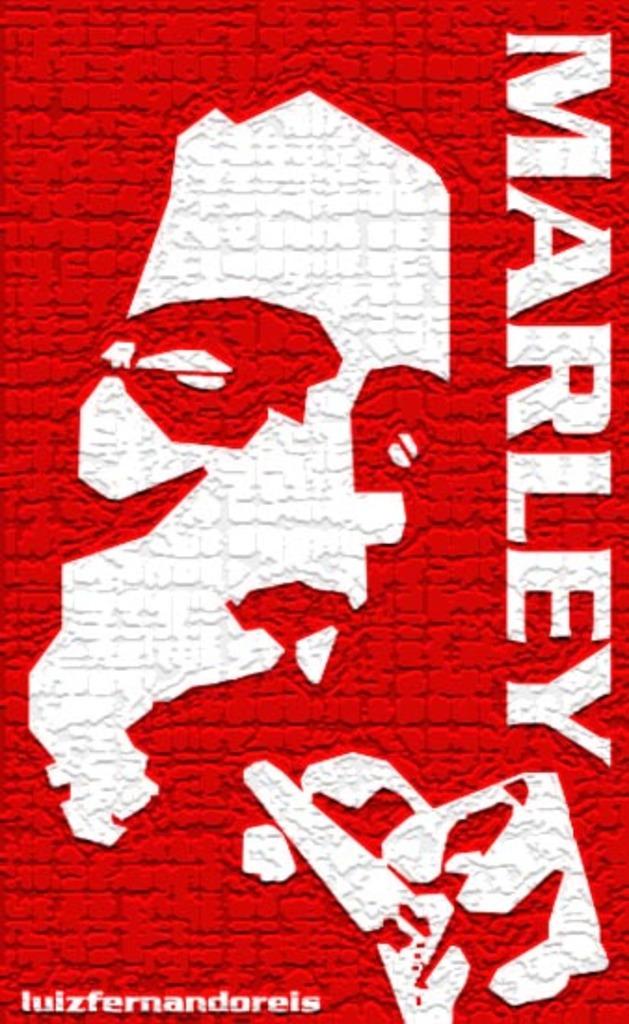Who is this?
Give a very brief answer. Marley. Who made this poster?
Your answer should be compact. Luizfernandoreis. 